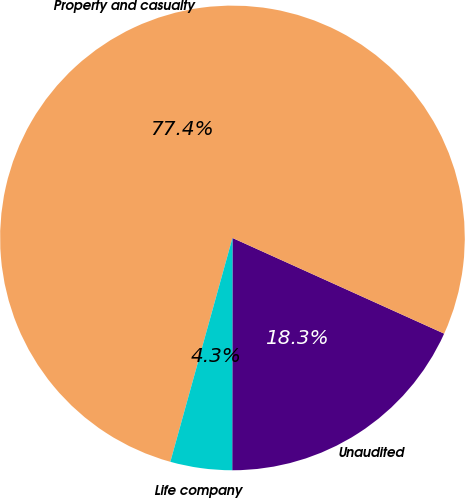Convert chart. <chart><loc_0><loc_0><loc_500><loc_500><pie_chart><fcel>Unaudited<fcel>Property and casualty<fcel>Life company<nl><fcel>18.26%<fcel>77.45%<fcel>4.29%<nl></chart> 